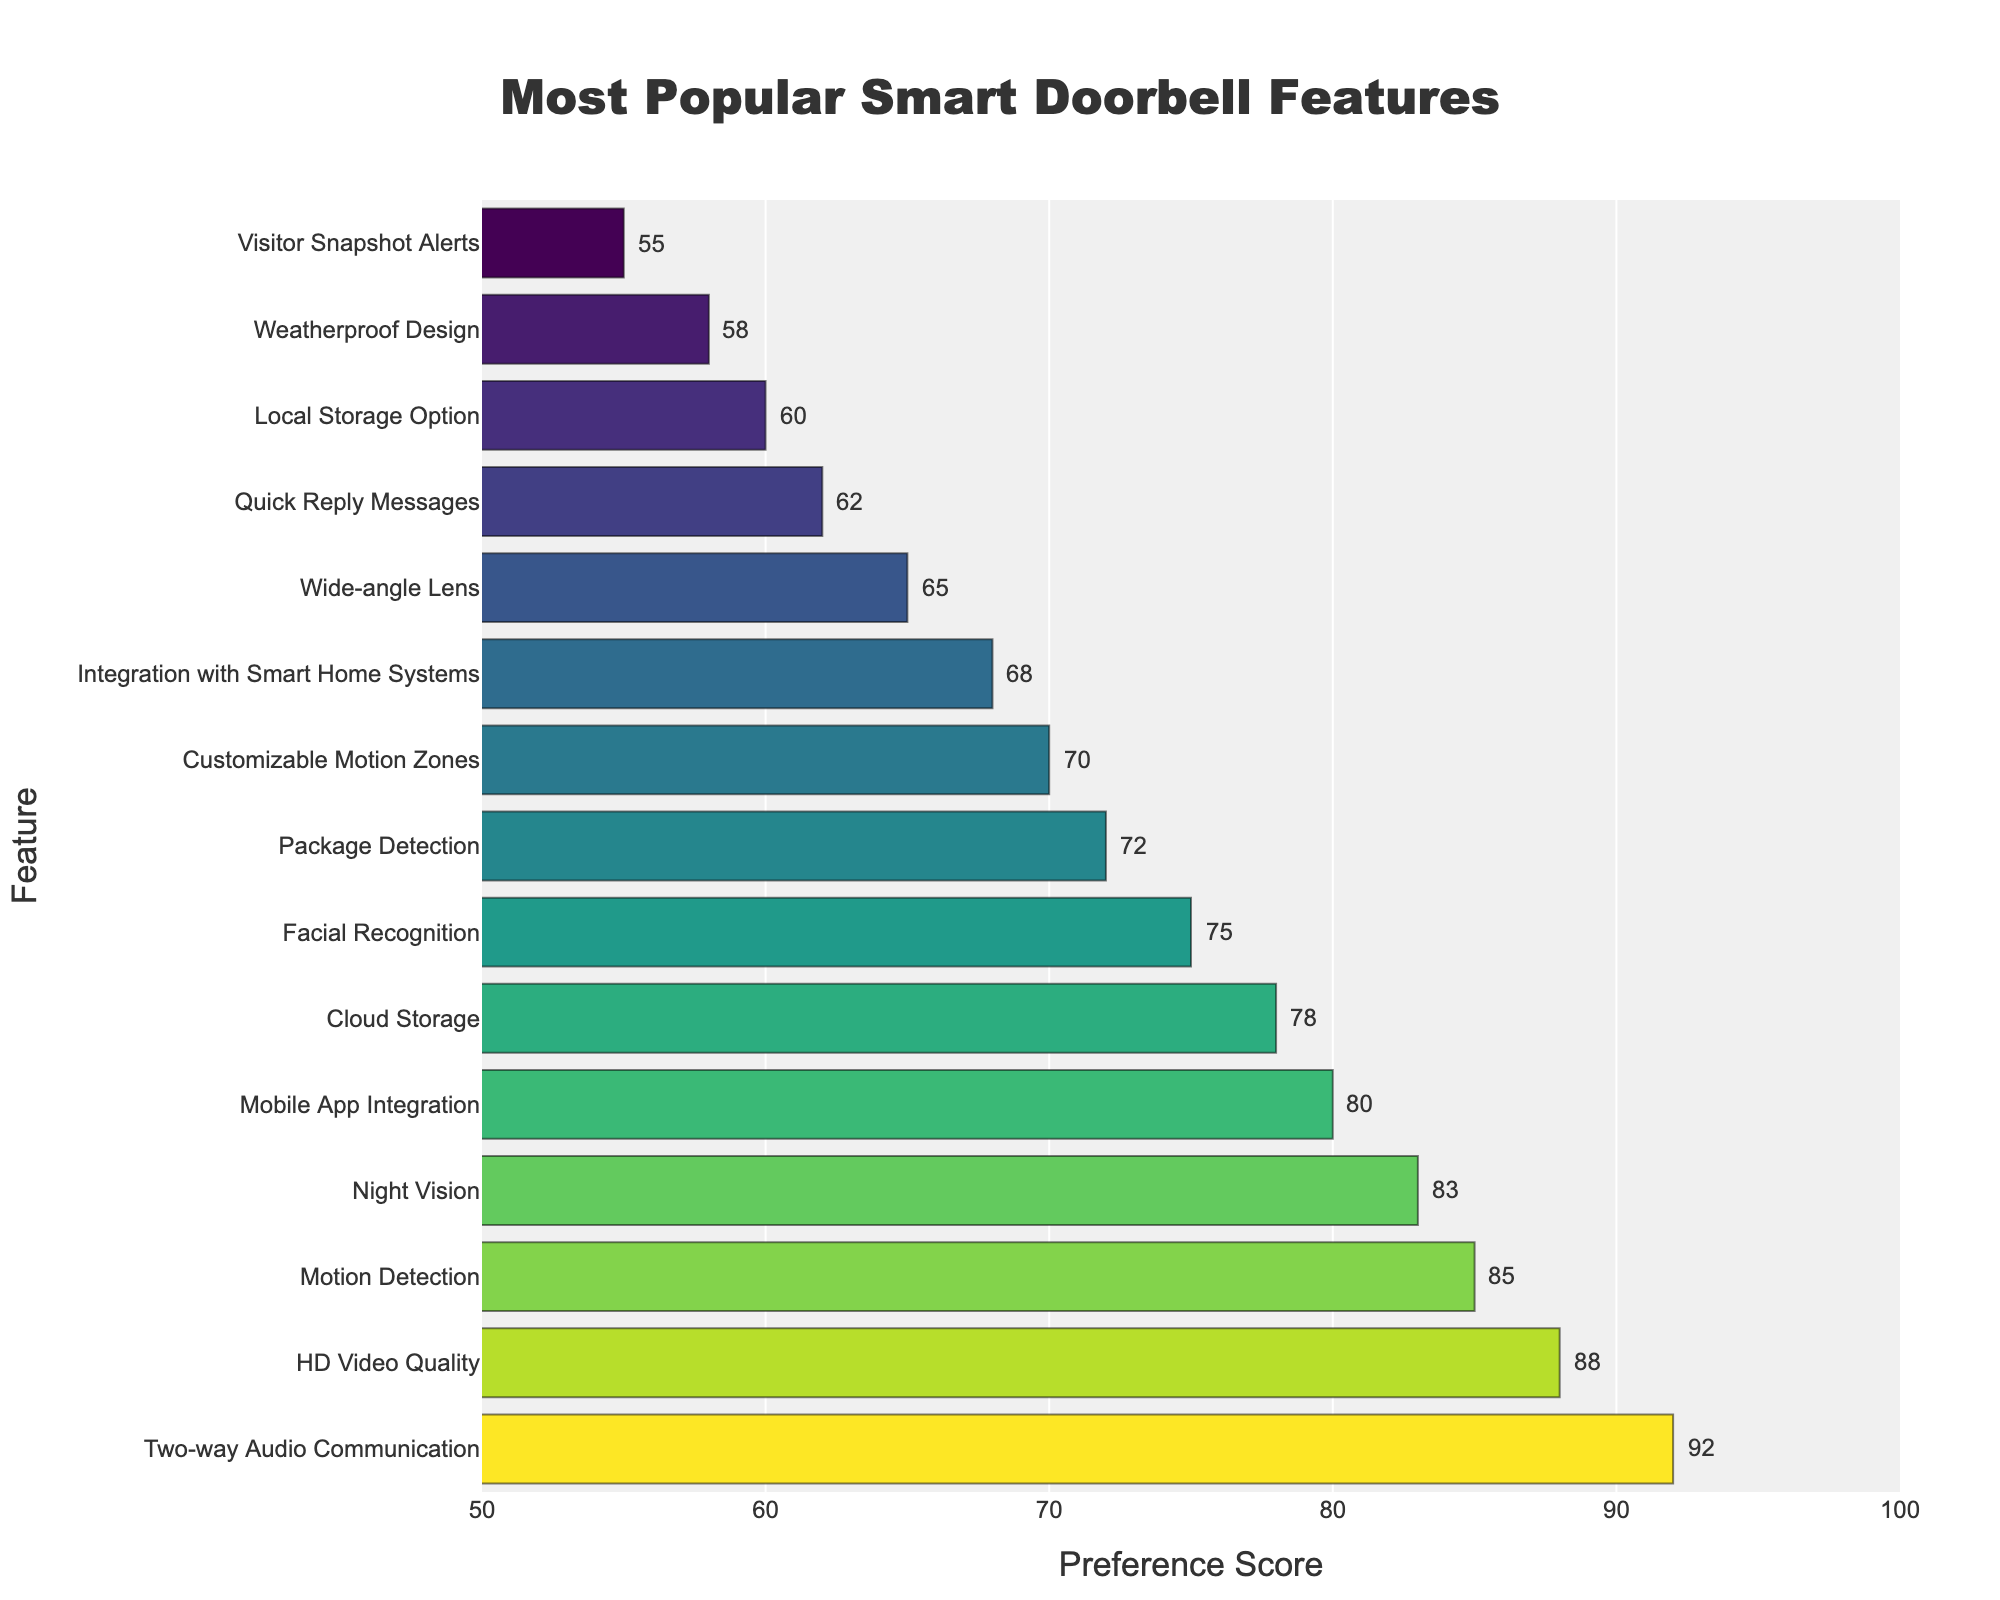Which feature has the highest preference score? The highest bar in the chart represents the feature with the highest preference score. By looking at the chart, the feature with the highest score is "Two-way Audio Communication".
Answer: Two-way Audio Communication How much higher is the preference score for "HD Video Quality" compared to "Wide-angle Lens"? The preference score for "HD Video Quality" is 88, and for "Wide-angle Lens" it is 65. The difference between these two scores is 88 - 65 = 23.
Answer: 23 Which features have a preference score of less than 70? Features with preference scores less than 70 can be identified by examining the bars that don't reach the 70 mark on the x-axis. These features are "Integration with Smart Home Systems", "Wide-angle Lens", "Quick Reply Messages", "Local Storage Option", "Weatherproof Design", and "Visitor Snapshot Alerts".
Answer: Integration with Smart Home Systems, Wide-angle Lens, Quick Reply Messages, Local Storage Option, Weatherproof Design, Visitor Snapshot Alerts What is the combined preference score for "Motion Detection" and "Night Vision"? The preference scores for "Motion Detection" and "Night Vision" are 85 and 83, respectively. Adding these scores together gives 85 + 83 = 168.
Answer: 168 How does the preference score for "Facial Recognition" compare to "Package Detection"? The preference scores for "Facial Recognition" and "Package Detection" are 75 and 72, respectively. "Facial Recognition" has a higher score by 75 - 72 = 3.
Answer: "Facial Recognition" is higher by 3 What is the average preference score of the top 3 features? The top 3 features are "Two-way Audio Communication" (92), "HD Video Quality" (88), and "Motion Detection" (85). The sum of these scores is 92 + 88 + 85 = 265. The average is 265 / 3 = 88.33.
Answer: 88.33 Which feature lies in the middle position when the features are ordered by preference score? In the sorted data, the middle feature is the one at the 8th position when there are 15 features in total. The feature in the 8th position is "Package Detection".
Answer: Package Detection Which feature has the lowest preference score, and what is that score? The shortest bar in the chart represents the feature with the lowest preference score. By looking at the chart, the feature with the lowest score is "Visitor Snapshot Alerts" with a score of 55.
Answer: Visitor Snapshot Alerts, 55 What is the difference in preference score between "Mobile App Integration" and "Local Storage Option"? The preference scores for "Mobile App Integration" and "Local Storage Option" are 80 and 60, respectively. The difference between these scores is 80 - 60 = 20.
Answer: 20 